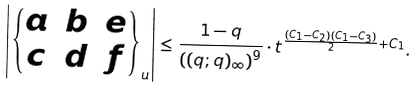<formula> <loc_0><loc_0><loc_500><loc_500>\left | \left \{ \begin{matrix} a & b & e \\ c & d & f \end{matrix} \right \} _ { u } \right | \leq \frac { 1 - q } { \left ( ( q ; q ) _ { \infty } \right ) ^ { 9 } } \cdot t ^ { \frac { ( C _ { 1 } - C _ { 2 } ) ( C _ { 1 } - C _ { 3 } ) } { 2 } + C _ { 1 } } .</formula> 